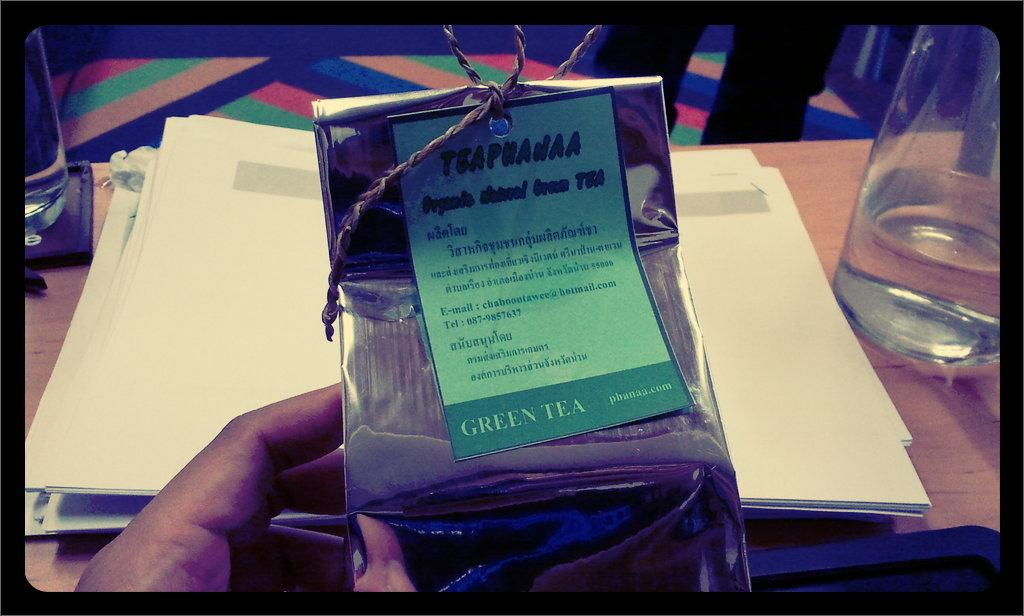<image>
Offer a succinct explanation of the picture presented. A small shiny bag tied with a string contains green tea. 